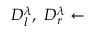<formula> <loc_0><loc_0><loc_500><loc_500>D _ { l } ^ { \lambda } , D _ { r } ^ { \lambda } \gets</formula> 